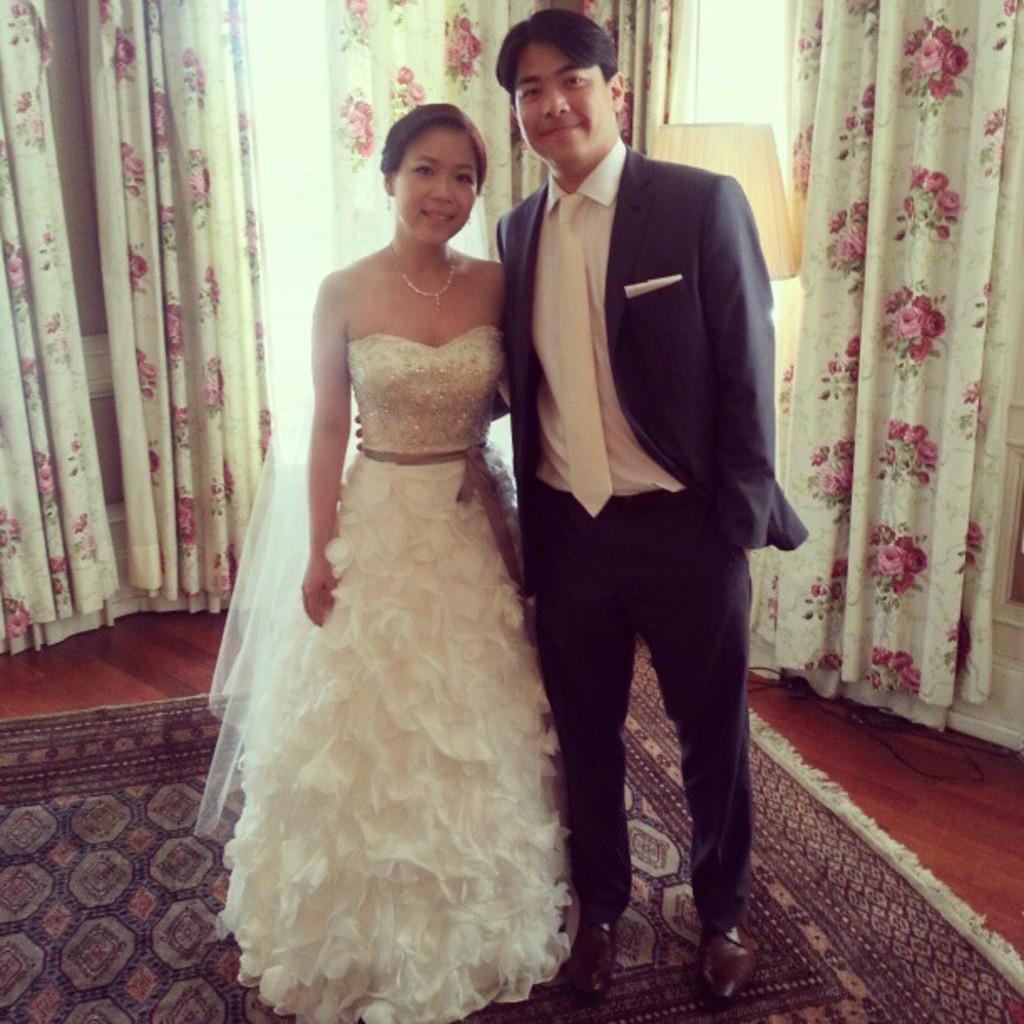How would you summarize this image in a sentence or two? This is the man and woman standing and smiling. I can see the carpet on the floor. These are the curtains, which are hanging. This looks like a lamp, which is behind the man. I think this is the window. 